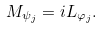<formula> <loc_0><loc_0><loc_500><loc_500>M _ { \psi _ { j } } = i L _ { \varphi _ { j } } .</formula> 